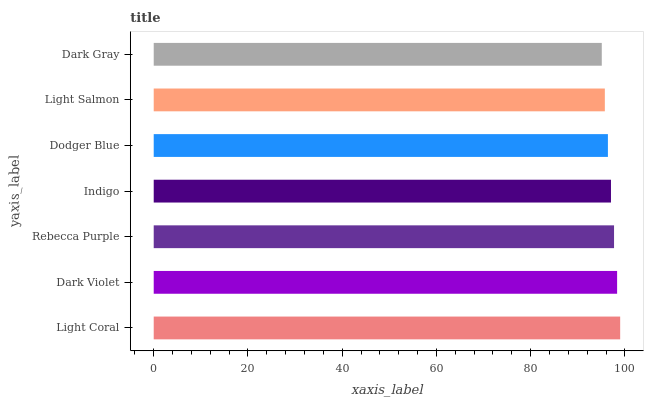Is Dark Gray the minimum?
Answer yes or no. Yes. Is Light Coral the maximum?
Answer yes or no. Yes. Is Dark Violet the minimum?
Answer yes or no. No. Is Dark Violet the maximum?
Answer yes or no. No. Is Light Coral greater than Dark Violet?
Answer yes or no. Yes. Is Dark Violet less than Light Coral?
Answer yes or no. Yes. Is Dark Violet greater than Light Coral?
Answer yes or no. No. Is Light Coral less than Dark Violet?
Answer yes or no. No. Is Indigo the high median?
Answer yes or no. Yes. Is Indigo the low median?
Answer yes or no. Yes. Is Rebecca Purple the high median?
Answer yes or no. No. Is Dark Gray the low median?
Answer yes or no. No. 